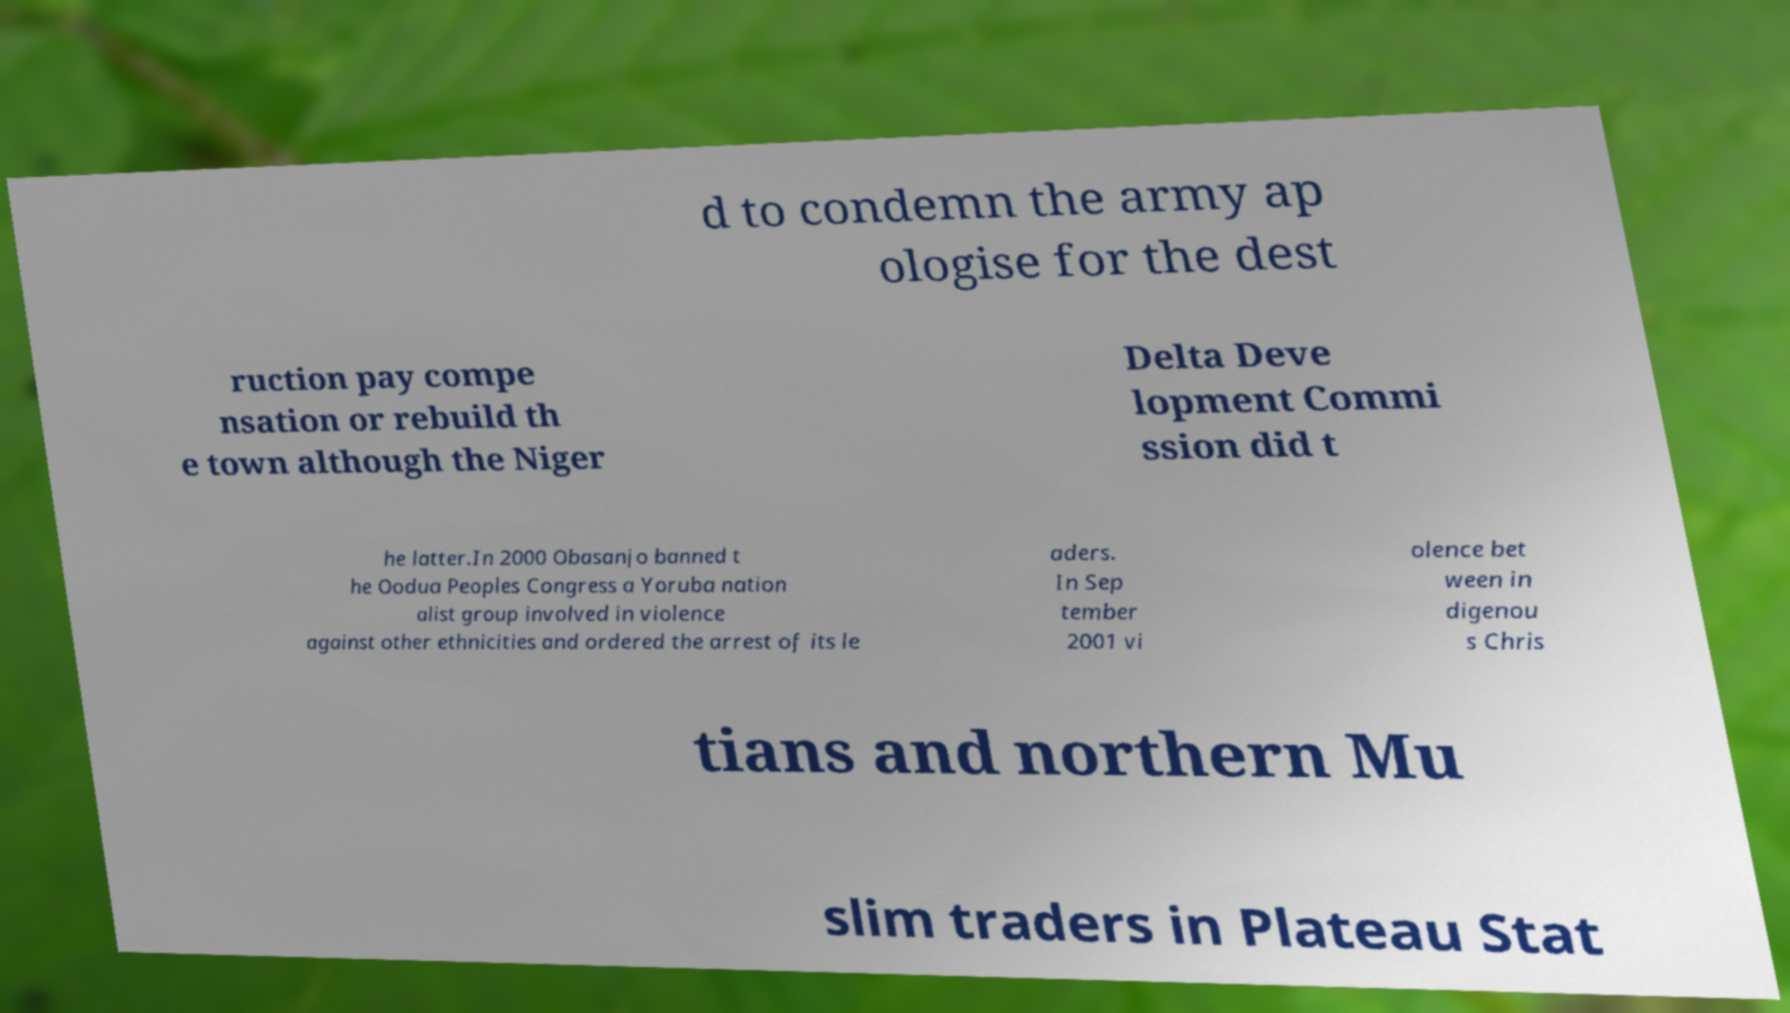I need the written content from this picture converted into text. Can you do that? d to condemn the army ap ologise for the dest ruction pay compe nsation or rebuild th e town although the Niger Delta Deve lopment Commi ssion did t he latter.In 2000 Obasanjo banned t he Oodua Peoples Congress a Yoruba nation alist group involved in violence against other ethnicities and ordered the arrest of its le aders. In Sep tember 2001 vi olence bet ween in digenou s Chris tians and northern Mu slim traders in Plateau Stat 